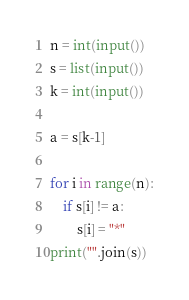<code> <loc_0><loc_0><loc_500><loc_500><_Python_>
n = int(input())
s = list(input())
k = int(input())

a = s[k-1]

for i in range(n):
    if s[i] != a:
        s[i] = "*"
print("".join(s))
</code> 